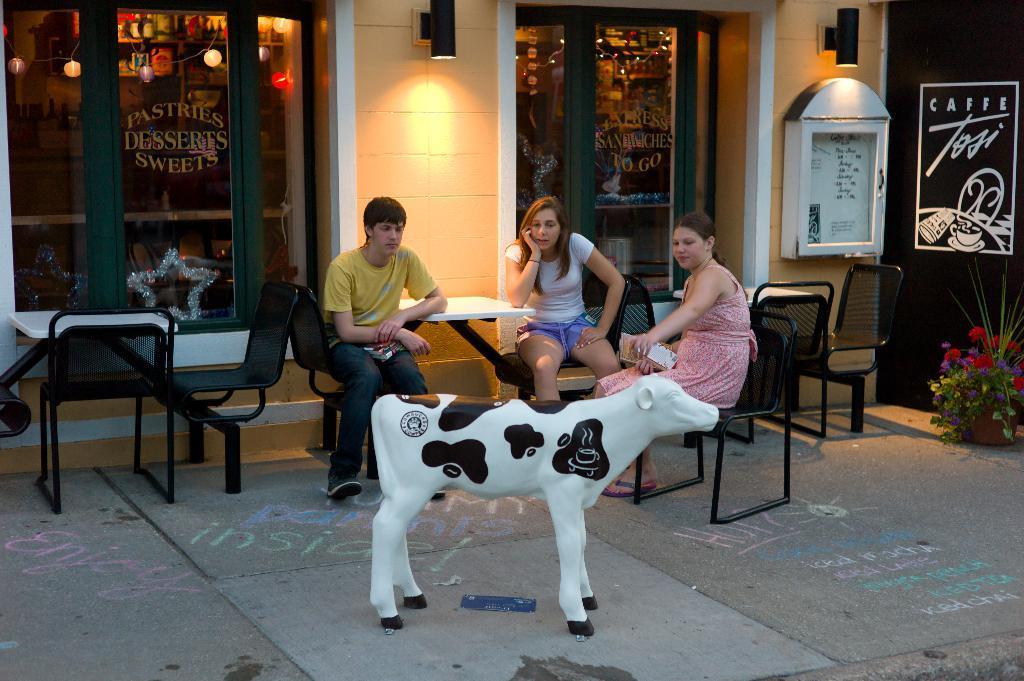Could you give a brief overview of what you see in this image? in this process there are three persons,one man and two women sitting on a chair,we can also see the calf and statue in front of them. 